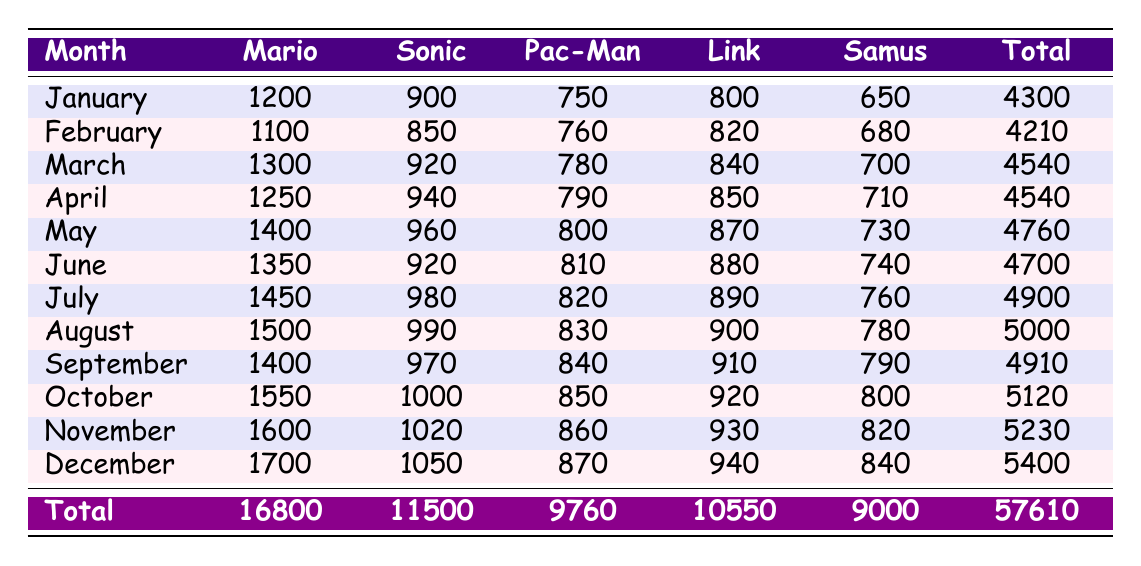What were the total earnings from merchandise sales in February? Looking at the table, the total earnings for February are explicitly listed in the Total column, which shows 4210.
Answer: 4210 Which character earned the most in December? In December, the individual earnings for each character are listed. Mario earned 1700, Sonic earned 1050, Pac-Man earned 870, Link earned 940, and Samus earned 840. Therefore, Mario earned the highest amount.
Answer: Mario What was the average earnings from merchandise sales for the character Link throughout the year? First, I sum Link's earnings across all months: 800 + 820 + 840 + 850 + 870 + 880 + 890 + 900 + 910 + 920 + 930 + 940 = 10550. Then, I divide this sum by the number of months, which is 12: 10550 / 12 = 879.17.
Answer: 879.17 Did Sonic’s earnings increase every month? By reviewing Sonic's monthly earnings from January to December, I see they were 900, 850, 920, 940, 960, 920, 980, 990, 970, 1000, 1020, 1050. Some months, his earnings decreased (January to February, and June to July). Therefore, the answer is no, there wasn't a consistent increase.
Answer: No What was the difference in total earnings between the highest and lowest month in 2022? I first identify the total earnings for each month from the Total column. The highest month is December with 5400 and the lowest is February with 4210. The difference is calculated as 5400 - 4210 = 1190.
Answer: 1190 Which month had the highest merchandise sales earnings overall? Analyzing the Total column, the highest earning month is December, which totaled 5400. All the monthly totals are compared visually or numerically to confirm this.
Answer: December What percentage of total earnings in 2022 did Mario’s earnings account for? Mario's total earnings throughout the year is 16800, and the total earnings for 2022 is 57610. The percentage is calculated as (16800 / 57610) * 100, which equals approximately 29.18%.
Answer: 29.18% Is it true that Samus earned more than Pac-Man in every month? By checking Samus's and Pac-Man's monthly earnings listed, I see Samus earned more in January, February, March, April, May, and June but not in July, August, September, October, November, and December, where Pac-Man's earnings were higher. Thus, the statement is false.
Answer: No 